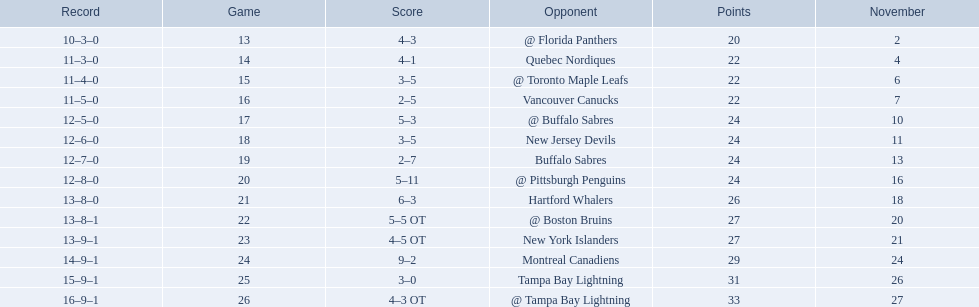Which teams scored 35 points or more in total? Hartford Whalers, @ Boston Bruins, New York Islanders, Montreal Canadiens, Tampa Bay Lightning, @ Tampa Bay Lightning. Of those teams, which team was the only one to score 3-0? Tampa Bay Lightning. 